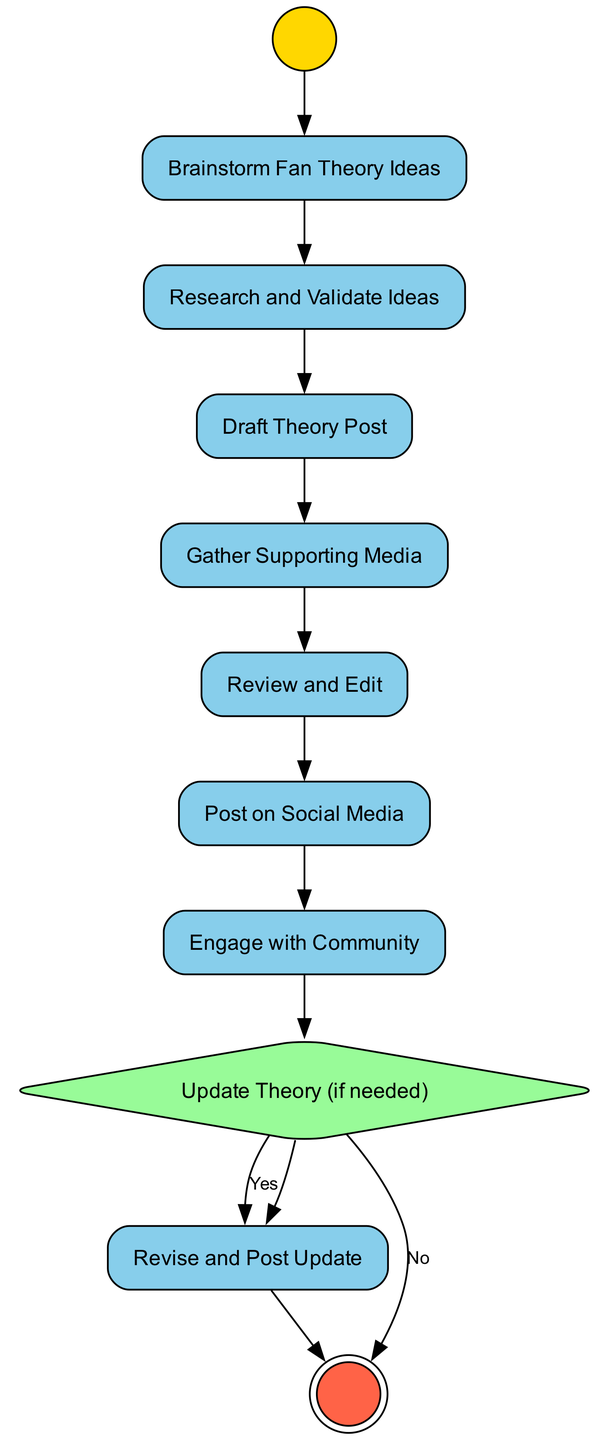What is the first action in the diagram? The first action node is labeled "Brainstorm Fan Theory Ideas." It follows the initial node, which indicates the starting point of the activity diagram.
Answer: Brainstorm Fan Theory Ideas How many action nodes are in the diagram? Counting the action nodes listed in the diagram, there are a total of five action nodes before the final node.
Answer: Five What comes after posting on social media? After "Post on Social Media," the next node is "Engage with Community," indicating the flow of actions that follows sharing the theory.
Answer: Engage with Community What decision is made after engaging with the community? The decision made after engaging with the community is labeled "Update Theory (if needed)," which determines if any revisions are necessary based on feedback.
Answer: Update Theory (if needed) What action follows the decision to update the theory? If the feedback is positive and requires changes, the next action would be "Revise and Post Update," indicating a revision process if necessary.
Answer: Revise and Post Update What type of node represents the starting point of the diagram? The starting point of the diagram is represented by an initial node, which is visually distinct and indicates where the activity begins.
Answer: Initial Node How many edges connect the nodes in the diagram? There are connections between each action and decision, providing a continuous flow throughout the diagram. Upon counting the connections, there are a total of eight edges.
Answer: Eight What two outcomes follow the decision "Update Theory (if needed)"? The outcomes that follow this decision are connected to two distinct actions: "Revise and Post Update" for "Yes" and "End" for "No."
Answer: Revise and Post Update, End 